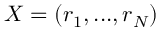<formula> <loc_0><loc_0><loc_500><loc_500>X = \left ( r _ { 1 } , \dots , r _ { N } \right )</formula> 